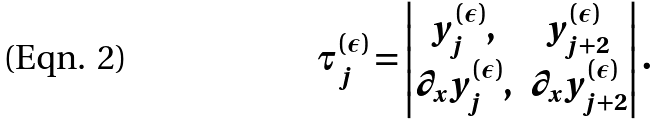Convert formula to latex. <formula><loc_0><loc_0><loc_500><loc_500>\tau ^ { ( \epsilon ) } _ { j } = \begin{vmatrix} y _ { j } ^ { ( \epsilon ) } , & y _ { j + 2 } ^ { ( \epsilon ) } \\ \partial _ { x } y _ { j } ^ { ( \epsilon ) } , & \partial _ { x } y _ { j + 2 } ^ { ( \epsilon ) } \\ \end{vmatrix} .</formula> 